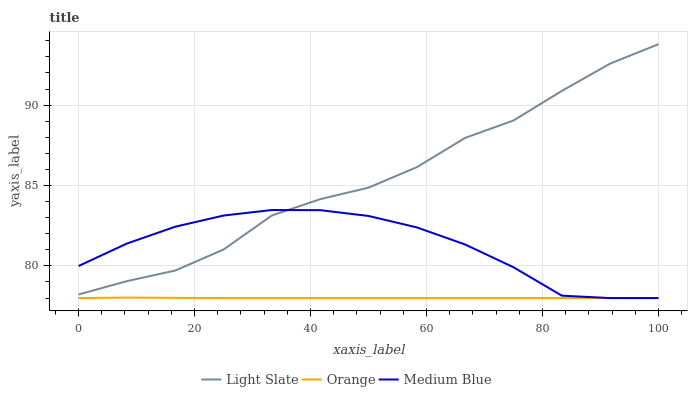Does Medium Blue have the minimum area under the curve?
Answer yes or no. No. Does Medium Blue have the maximum area under the curve?
Answer yes or no. No. Is Medium Blue the smoothest?
Answer yes or no. No. Is Medium Blue the roughest?
Answer yes or no. No. Does Medium Blue have the highest value?
Answer yes or no. No. Is Orange less than Light Slate?
Answer yes or no. Yes. Is Light Slate greater than Orange?
Answer yes or no. Yes. Does Orange intersect Light Slate?
Answer yes or no. No. 